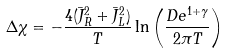<formula> <loc_0><loc_0><loc_500><loc_500>\Delta \chi = - \frac { 4 ( \bar { J } _ { R } ^ { 2 } + \bar { J } _ { L } ^ { 2 } ) } { T } \ln \left ( \frac { D e ^ { 1 + \gamma } } { 2 \pi T } \right )</formula> 